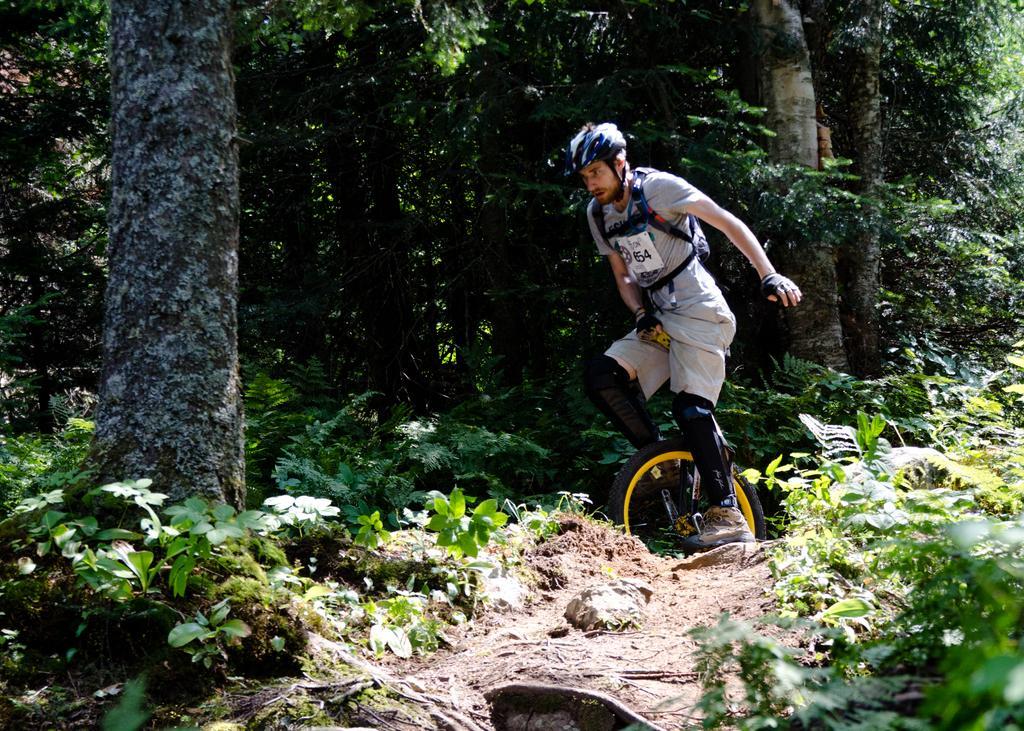In one or two sentences, can you explain what this image depicts? In this image we can see a person wearing a helmet riding a unicycle. We can also see the bark of a tree, some plants and a group of trees. 